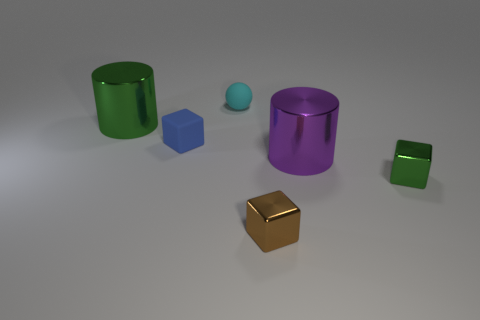Which object stands out the most to you? The gold cube stands out due to its position at the forefront and its distinct, metallic color that differs from the cooler hues of the other objects in the image. 